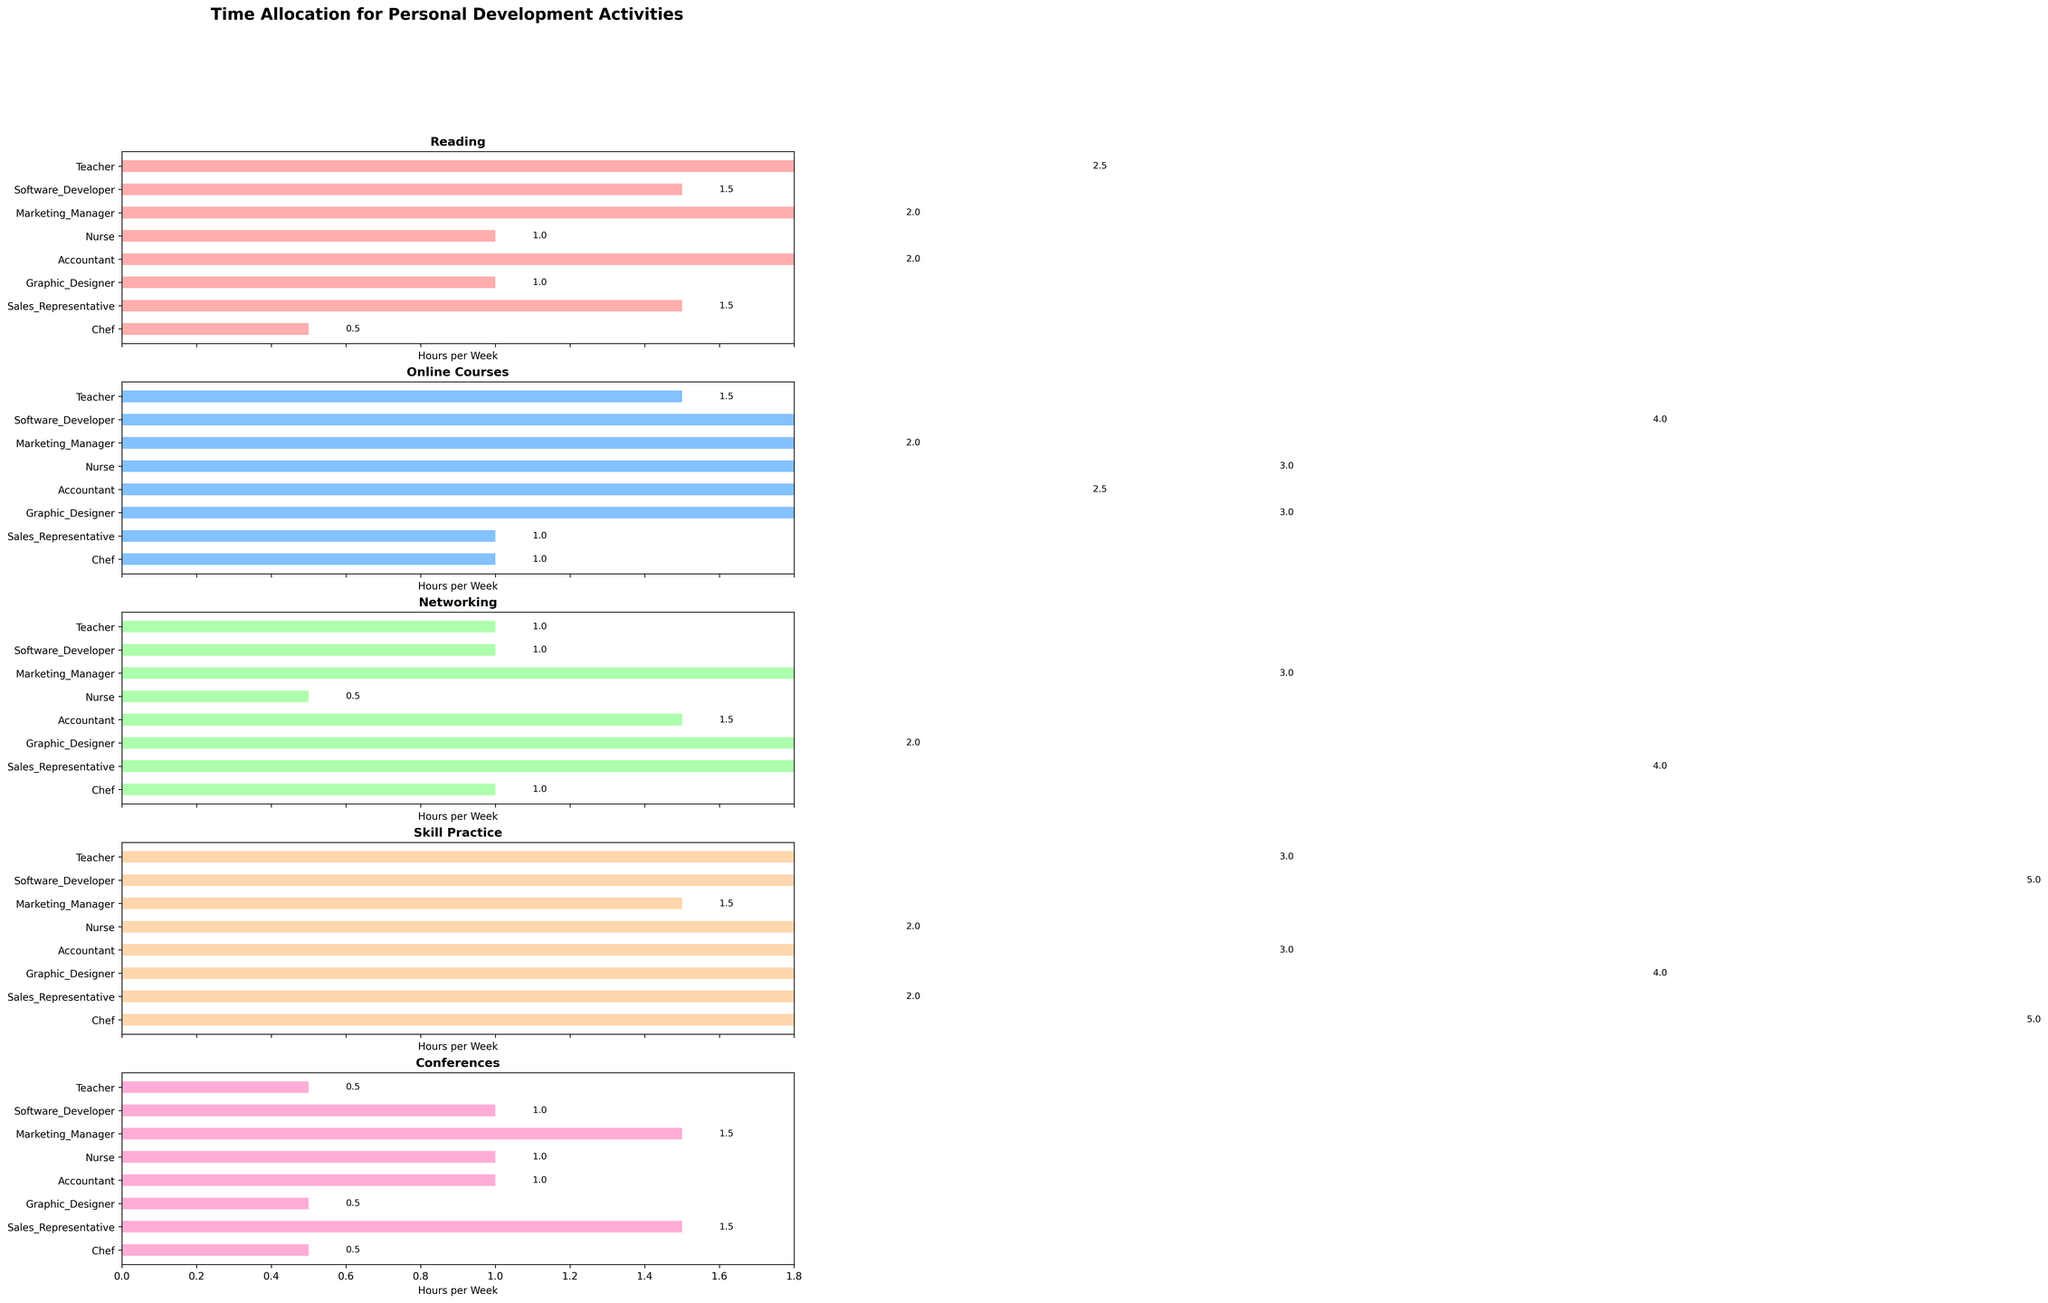What's the title of the figure? The title is usually placed at the top of the figure. In this case, it is mentioned in the code with `fig.suptitle()`. The title reads "Time Allocation for Personal Development Activities."
Answer: Time Allocation for Personal Development Activities What activity do teachers spend the most time on? By looking at the subplot that corresponds to Teachers, we see the largest bar, indicating the most time spent, is in "Skill Practice." The value is 3 hours per week.
Answer: Skill Practice Which career spends the least amount of time reading? In the "Reading" subplot, the shortest bar corresponds to the career 'Chef,' indicating they spend the least amount of time reading. The value is 0.5 hours per week.
Answer: Chef What is the combined total time nurses spend on all activities? By adding the time values from all subplots for the career 'Nurse': 1 (Reading) + 3 (Online Courses) + 0.5 (Networking) + 2 (Skill Practice) + 1 (Conferences) = 7.5 hours per week.
Answer: 7.5 Which career spends more time on Networking, Sales Representatives or Graphic Designers? In the "Networking" subplot, compare the bars for Sales Representatives and Graphic Designers. Sales Representatives spend 4 hours, while Graphic Designers spend 2 hours.
Answer: Sales Representatives What is the average time spent on Online Courses by all careers? Summing the time for Online Courses across all careers: 1.5 + 4 + 2 + 3 + 2.5 + 3 + 1 + 1 = 18, and dividing by the number of careers (8), the average is 18/8 = 2.25 hours per week.
Answer: 2.25 Which career has the highest variance in time spent across all activities? To find this, we look for the career with the most variation in bar lengths across all the subplots. Software Developer shows significant variation: 1.5 + 4 + 1 + 5 + 1.5 = 13.5, with wide differences in individual activities.
Answer: Software Developer Do Marketing Managers spend more time on Networking than on Skill Practice? By examining the respective subplot bars, Marketing Managers spend 3 hours on Networking and 1.5 hours on Skill Practice, so they spend more time on Networking.
Answer: Yes Which activity has the narrowest range of time spent among all careers? By looking across all subplots, we observe the ranges. "Networking" has values from 0.5 to 4, but "Conferences" has values from 0.5 to 1.5, making its range narrower.
Answer: Conferences Which career spends twice as much time on Reading as Sales Representatives do? Sales Representatives spend 1.5 hours on Reading, so we look for a career spending 3 hours. No career spends exactly 3 hours, but Accountant and Marketing Manager both spend 2 hours, closest to twice the time.
Answer: None 